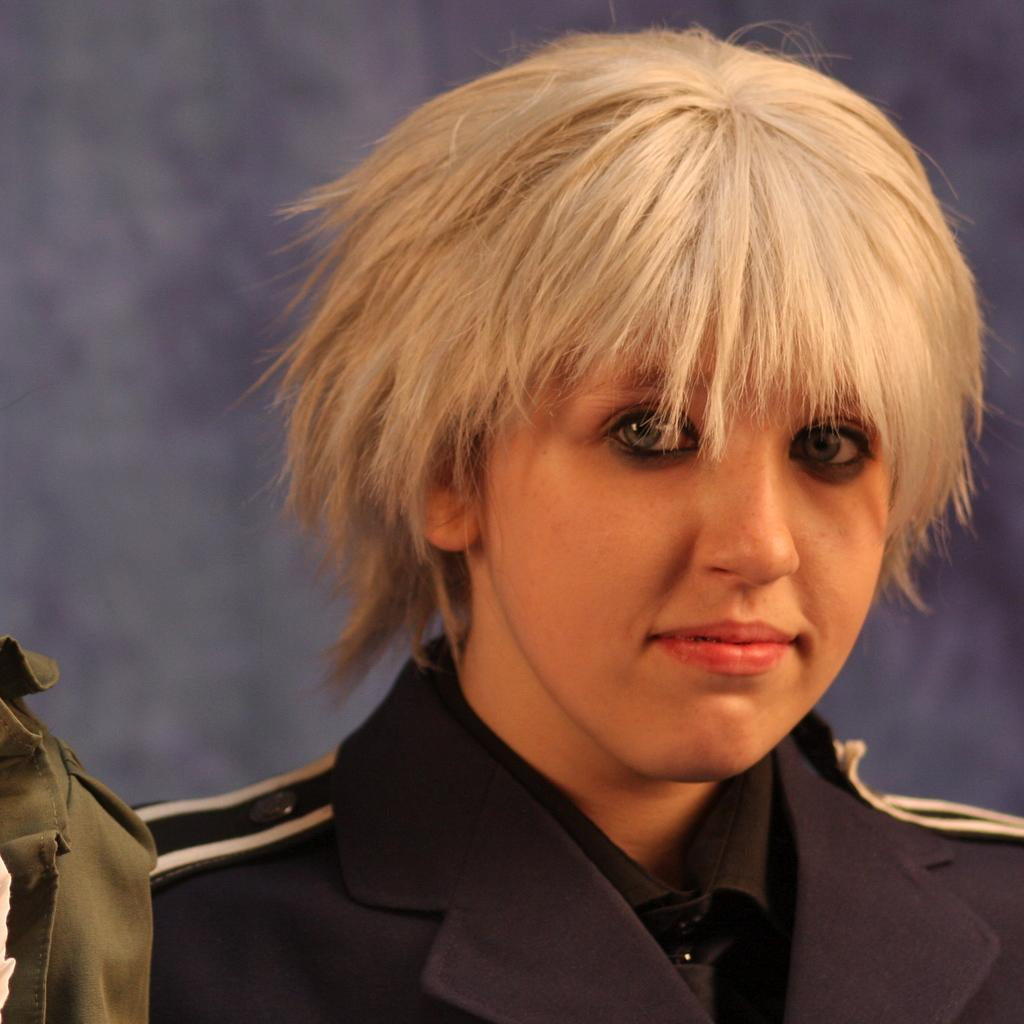What is the person in the image wearing? The person in the image is wearing a uniform. What else can be seen in the image besides the person? There is a cloth visible in the image. What is in the background of the image? There is a wall in the background of the image. What type of milk is being used to support the wall in the image? There is no milk or support for the wall visible in the image. 